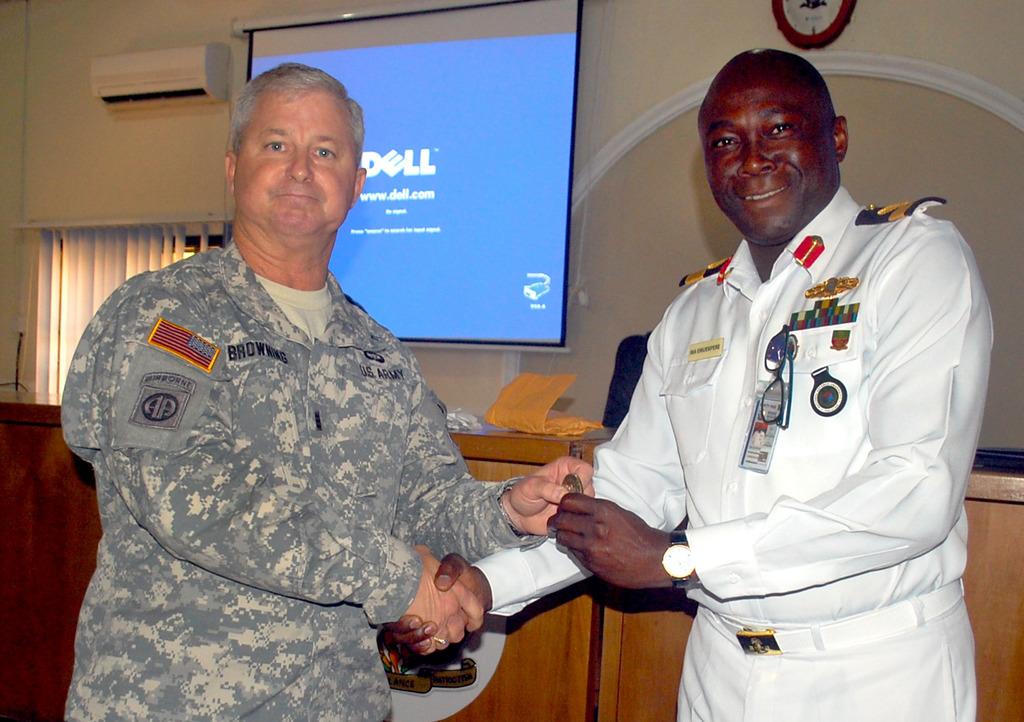What brand projector is in use in the background?
Offer a very short reply. Dell. Which branch of the military is on the man on the left?
Keep it short and to the point. Army. 